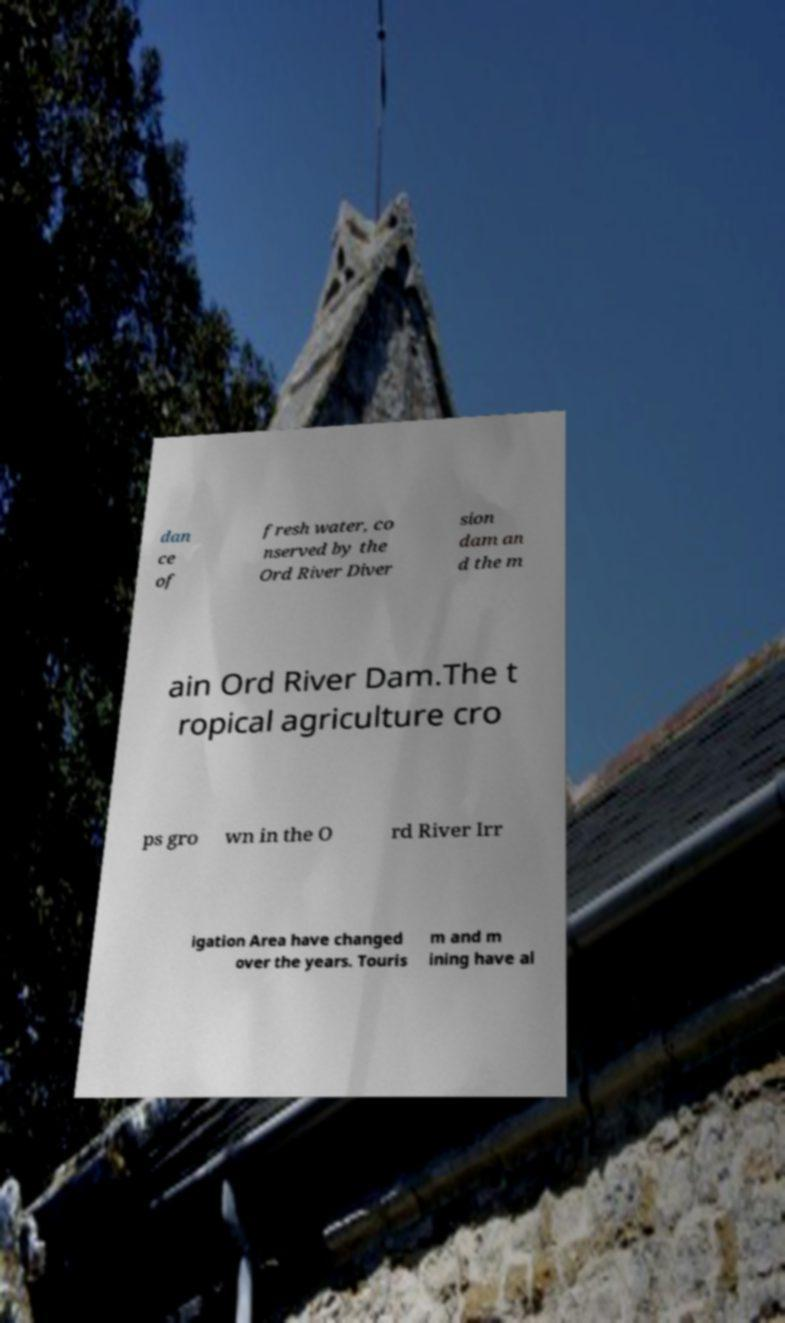Can you read and provide the text displayed in the image?This photo seems to have some interesting text. Can you extract and type it out for me? dan ce of fresh water, co nserved by the Ord River Diver sion dam an d the m ain Ord River Dam.The t ropical agriculture cro ps gro wn in the O rd River Irr igation Area have changed over the years. Touris m and m ining have al 